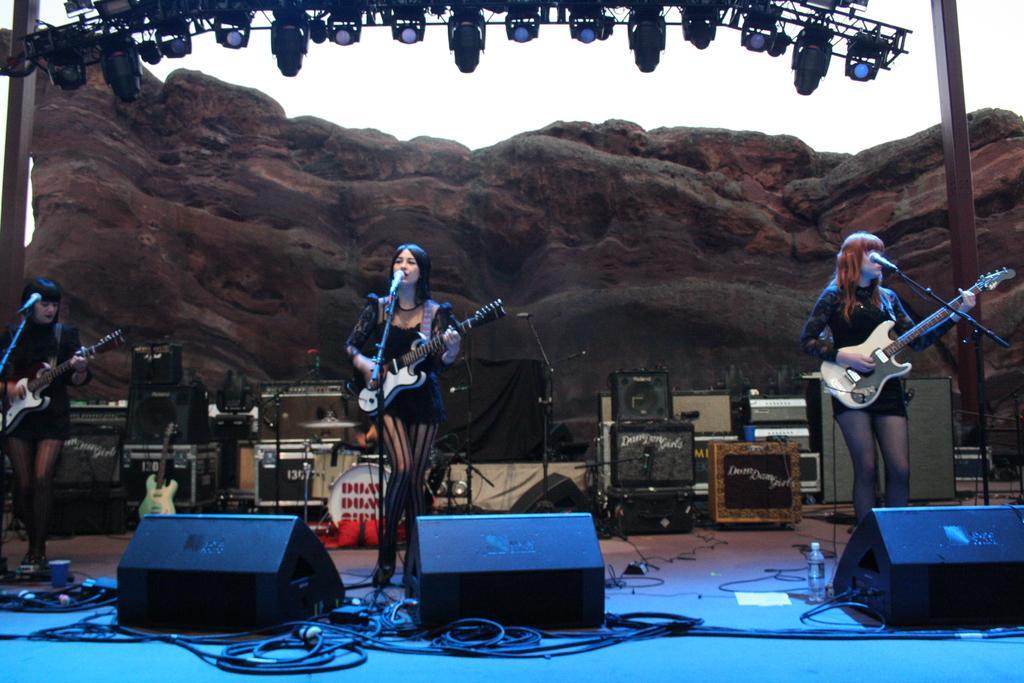Can you describe this image briefly? This is looking like a stage and girl is holding a guitar and playing and singing. And in front of her there is a mic stand. Another girl is holding a guitar and playing. There are so many speakers and wires in the stage. On the left corner there is a girl holding guitar and playing. In the background there is a rock also a arch of light settings are there. And two pillars are over there. 